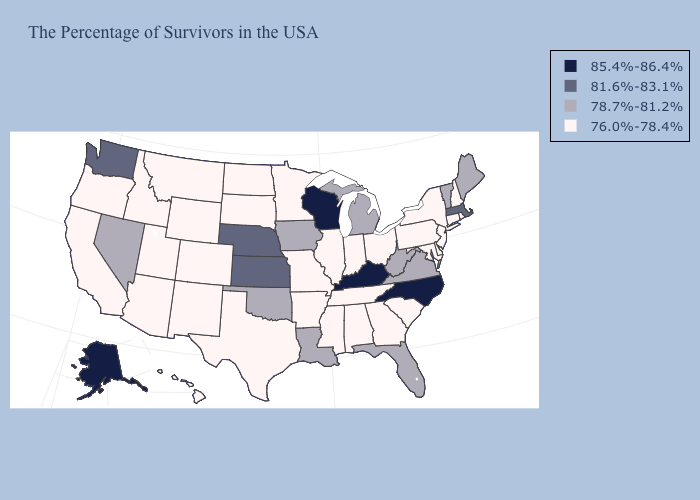Does Mississippi have the lowest value in the USA?
Write a very short answer. Yes. What is the lowest value in the USA?
Be succinct. 76.0%-78.4%. Name the states that have a value in the range 81.6%-83.1%?
Keep it brief. Massachusetts, Kansas, Nebraska, Washington. Name the states that have a value in the range 85.4%-86.4%?
Keep it brief. North Carolina, Kentucky, Wisconsin, Alaska. Does Georgia have the same value as Idaho?
Give a very brief answer. Yes. Among the states that border Michigan , does Wisconsin have the lowest value?
Give a very brief answer. No. What is the highest value in the USA?
Be succinct. 85.4%-86.4%. Does West Virginia have a higher value than Nevada?
Short answer required. No. Does Pennsylvania have the lowest value in the USA?
Concise answer only. Yes. What is the highest value in the USA?
Write a very short answer. 85.4%-86.4%. Name the states that have a value in the range 85.4%-86.4%?
Answer briefly. North Carolina, Kentucky, Wisconsin, Alaska. What is the highest value in states that border Mississippi?
Concise answer only. 78.7%-81.2%. What is the lowest value in the South?
Be succinct. 76.0%-78.4%. Does the map have missing data?
Keep it brief. No. Does the map have missing data?
Concise answer only. No. 